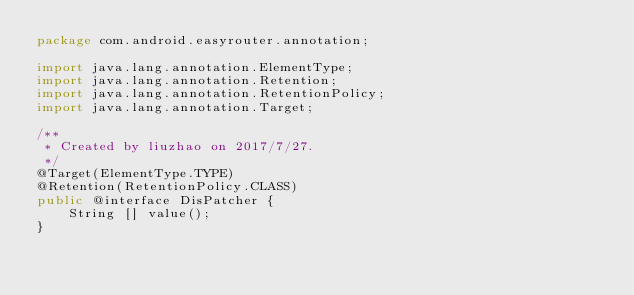<code> <loc_0><loc_0><loc_500><loc_500><_Java_>package com.android.easyrouter.annotation;

import java.lang.annotation.ElementType;
import java.lang.annotation.Retention;
import java.lang.annotation.RetentionPolicy;
import java.lang.annotation.Target;

/**
 * Created by liuzhao on 2017/7/27.
 */
@Target(ElementType.TYPE)
@Retention(RetentionPolicy.CLASS)
public @interface DisPatcher {
    String [] value();
}
</code> 